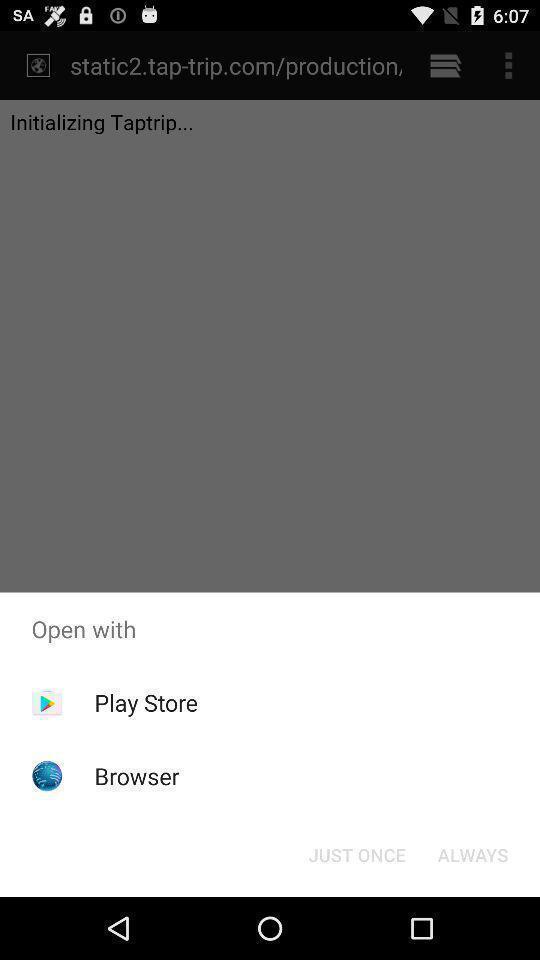Provide a textual representation of this image. Popup to select the app for opening the selected file. 